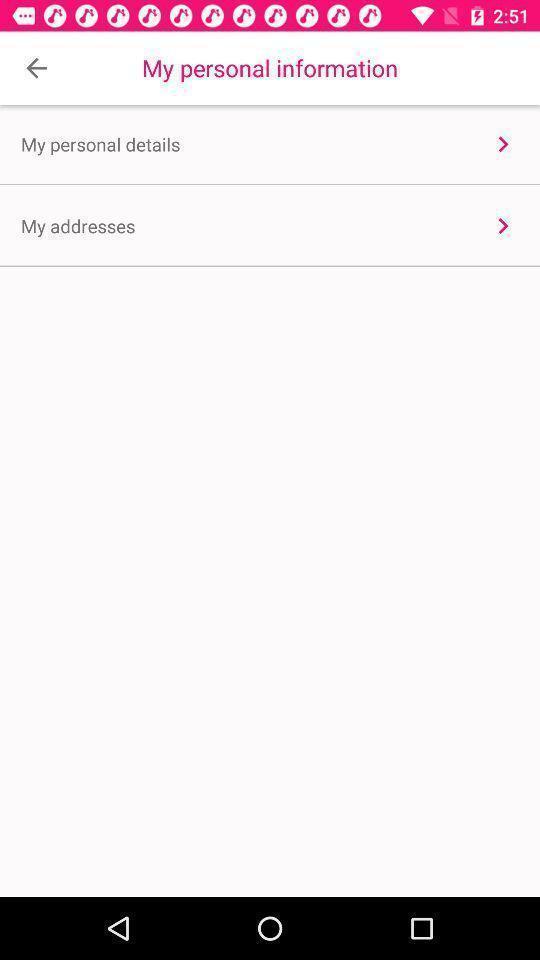Provide a description of this screenshot. Screen displaying options. 